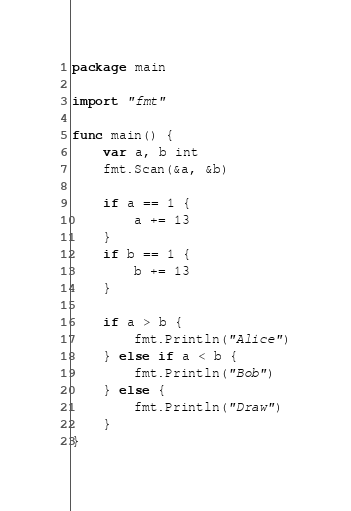Convert code to text. <code><loc_0><loc_0><loc_500><loc_500><_Go_>package main

import "fmt"

func main() {
	var a, b int
	fmt.Scan(&a, &b)

	if a == 1 {
		a += 13
	}
	if b == 1 {
		b += 13
	}

	if a > b {
		fmt.Println("Alice")
	} else if a < b {
		fmt.Println("Bob")
	} else {
		fmt.Println("Draw")
	}
}
</code> 